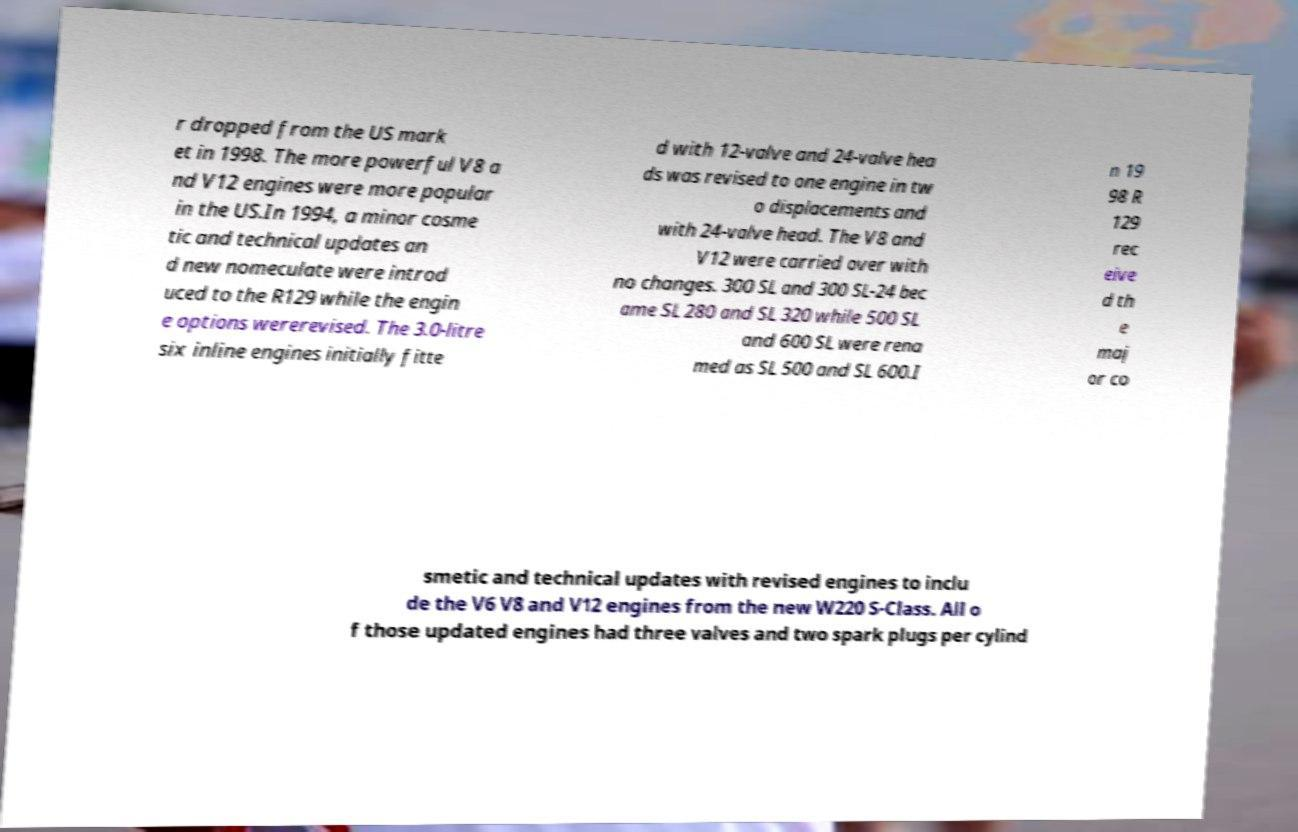Please read and relay the text visible in this image. What does it say? r dropped from the US mark et in 1998. The more powerful V8 a nd V12 engines were more popular in the US.In 1994, a minor cosme tic and technical updates an d new nomeculate were introd uced to the R129 while the engin e options wererevised. The 3.0-litre six inline engines initially fitte d with 12-valve and 24-valve hea ds was revised to one engine in tw o displacements and with 24-valve head. The V8 and V12 were carried over with no changes. 300 SL and 300 SL-24 bec ame SL 280 and SL 320 while 500 SL and 600 SL were rena med as SL 500 and SL 600.I n 19 98 R 129 rec eive d th e maj or co smetic and technical updates with revised engines to inclu de the V6 V8 and V12 engines from the new W220 S-Class. All o f those updated engines had three valves and two spark plugs per cylind 